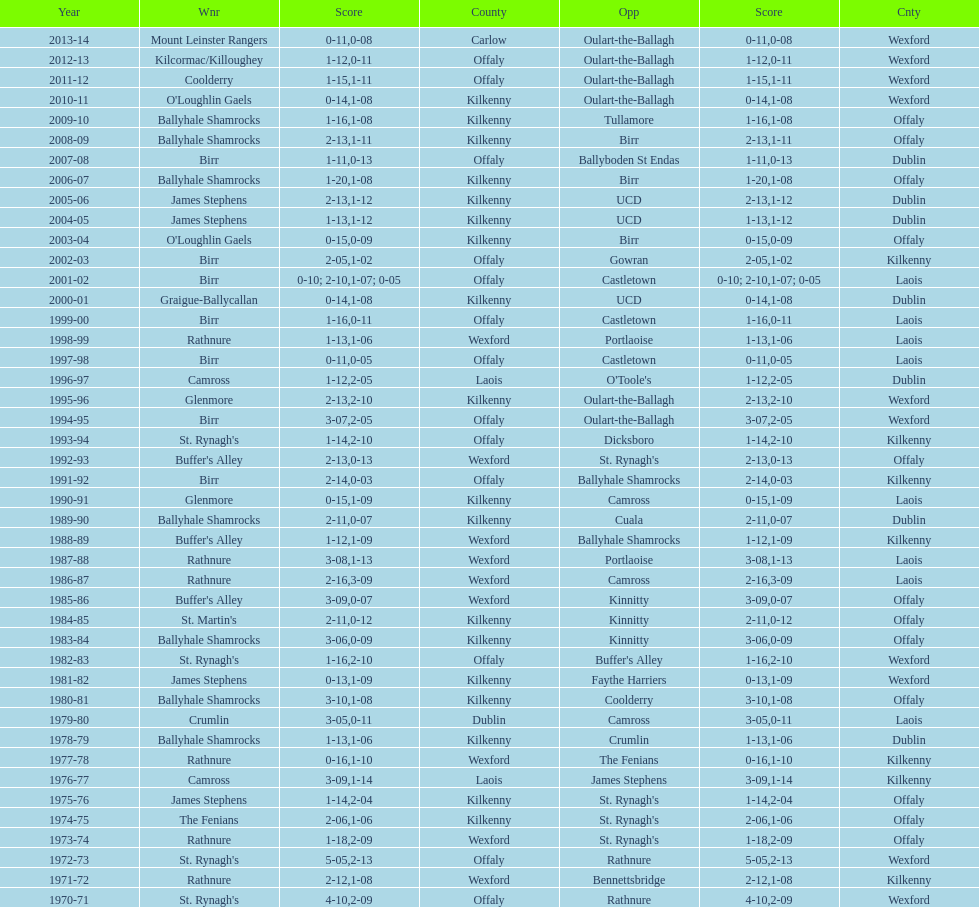What was the last season the leinster senior club hurling championships was won by a score differential of less than 11? 2007-08. 